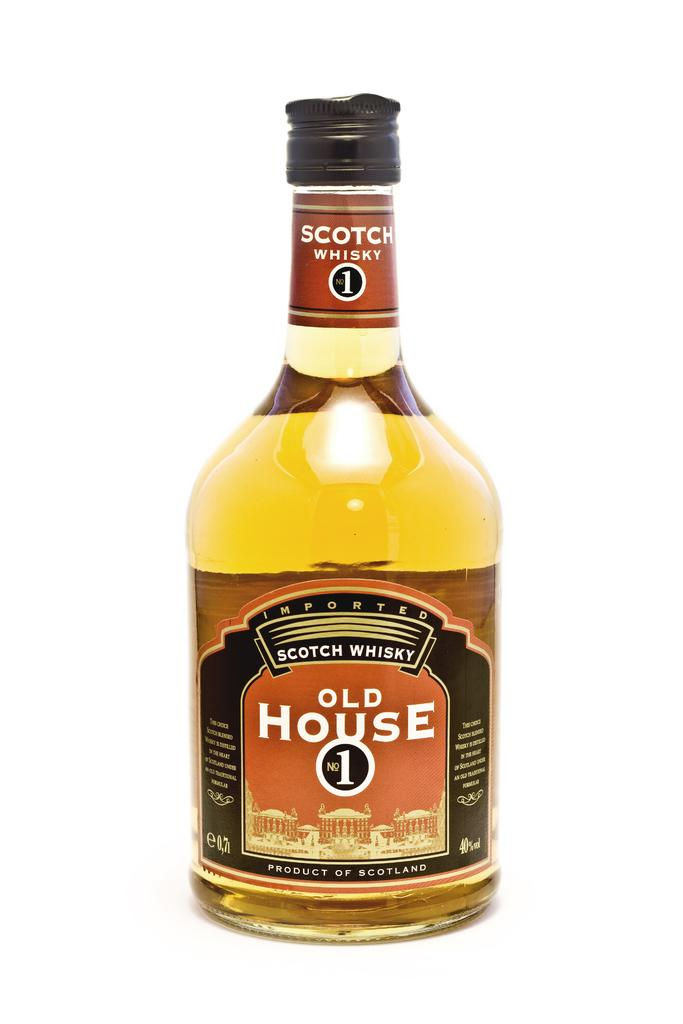<image>
Summarize the visual content of the image. A bottle of Old House No.1 Scotch is positioned on a white background 